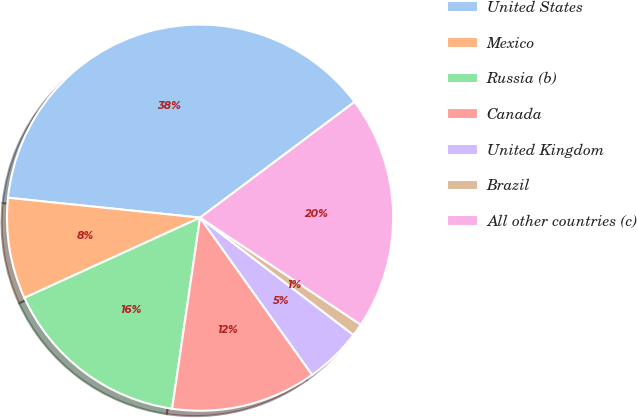Convert chart. <chart><loc_0><loc_0><loc_500><loc_500><pie_chart><fcel>United States<fcel>Mexico<fcel>Russia (b)<fcel>Canada<fcel>United Kingdom<fcel>Brazil<fcel>All other countries (c)<nl><fcel>38.12%<fcel>8.46%<fcel>15.87%<fcel>12.17%<fcel>4.75%<fcel>1.04%<fcel>19.58%<nl></chart> 